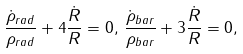<formula> <loc_0><loc_0><loc_500><loc_500>\frac { \dot { \rho } _ { r a d } } { { \rho } _ { r a d } } + 4 \frac { \dot { R } } { R } = 0 , \, \frac { \dot { \rho } _ { b a r } } { { \rho } _ { b a r } } + 3 \frac { \dot { R } } { R } = 0 ,</formula> 